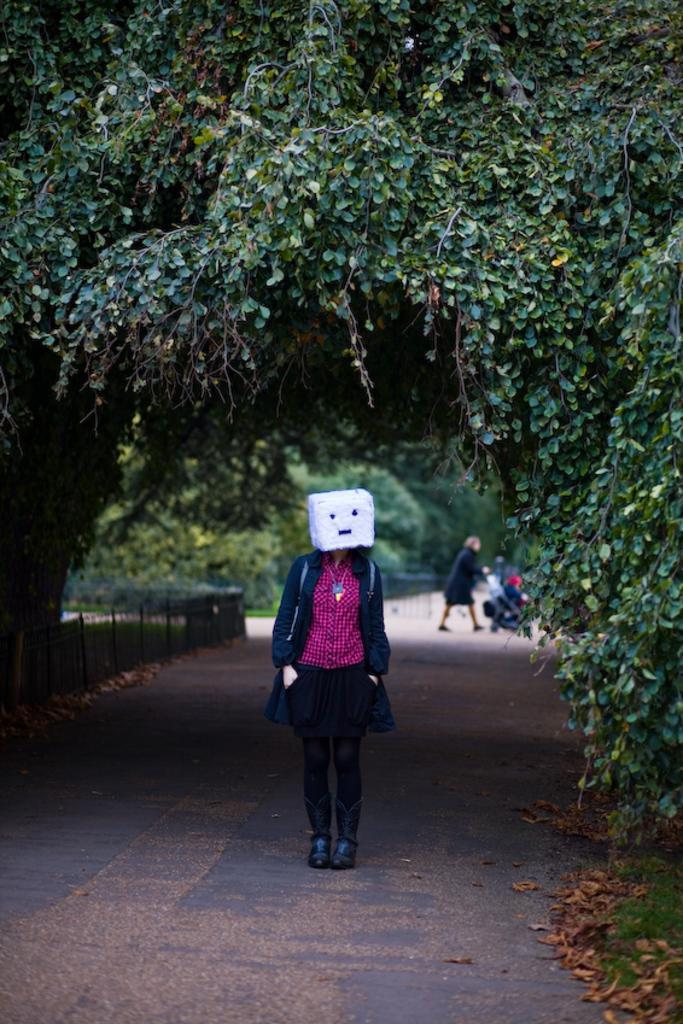Who or what can be seen in the image? There are people in the image. What type of furniture is present in the image? There is a baby chair in the image. What type of natural elements are visible in the image? There are trees in the image. What architectural feature can be seen in the image? There are railings in the image. Can you describe any other objects in the image? There are objects in the image, but their specific nature is not mentioned in the facts. What type of vest is the baby wearing in the image? There is no baby or vest mentioned in the image; it only states that there is a baby chair present. 